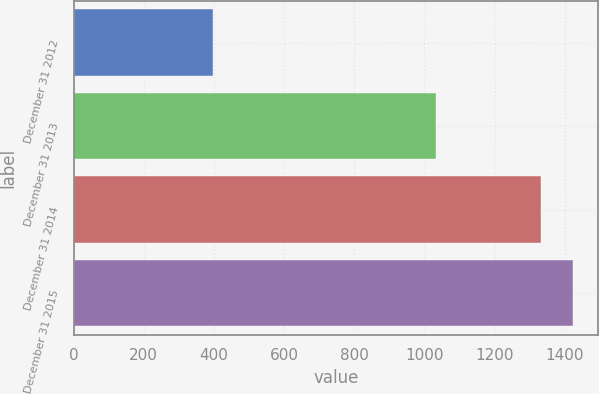Convert chart. <chart><loc_0><loc_0><loc_500><loc_500><bar_chart><fcel>December 31 2012<fcel>December 31 2013<fcel>December 31 2014<fcel>December 31 2015<nl><fcel>398<fcel>1034<fcel>1331<fcel>1424.3<nl></chart> 